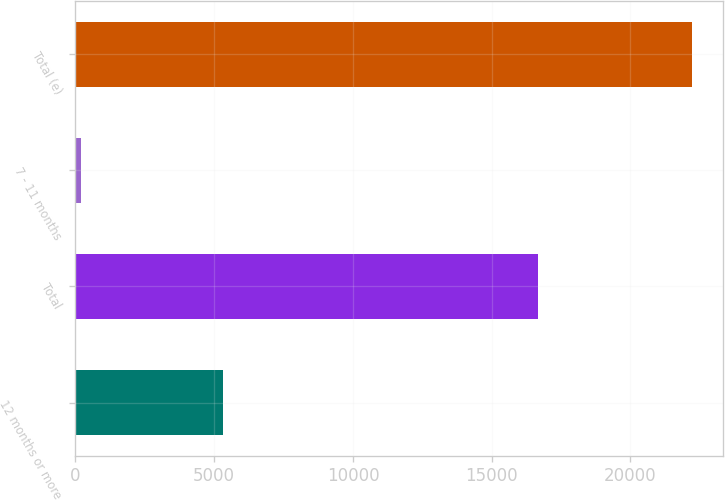Convert chart. <chart><loc_0><loc_0><loc_500><loc_500><bar_chart><fcel>12 months or more<fcel>Total<fcel>7 - 11 months<fcel>Total (e)<nl><fcel>5323<fcel>16653<fcel>193<fcel>22224<nl></chart> 